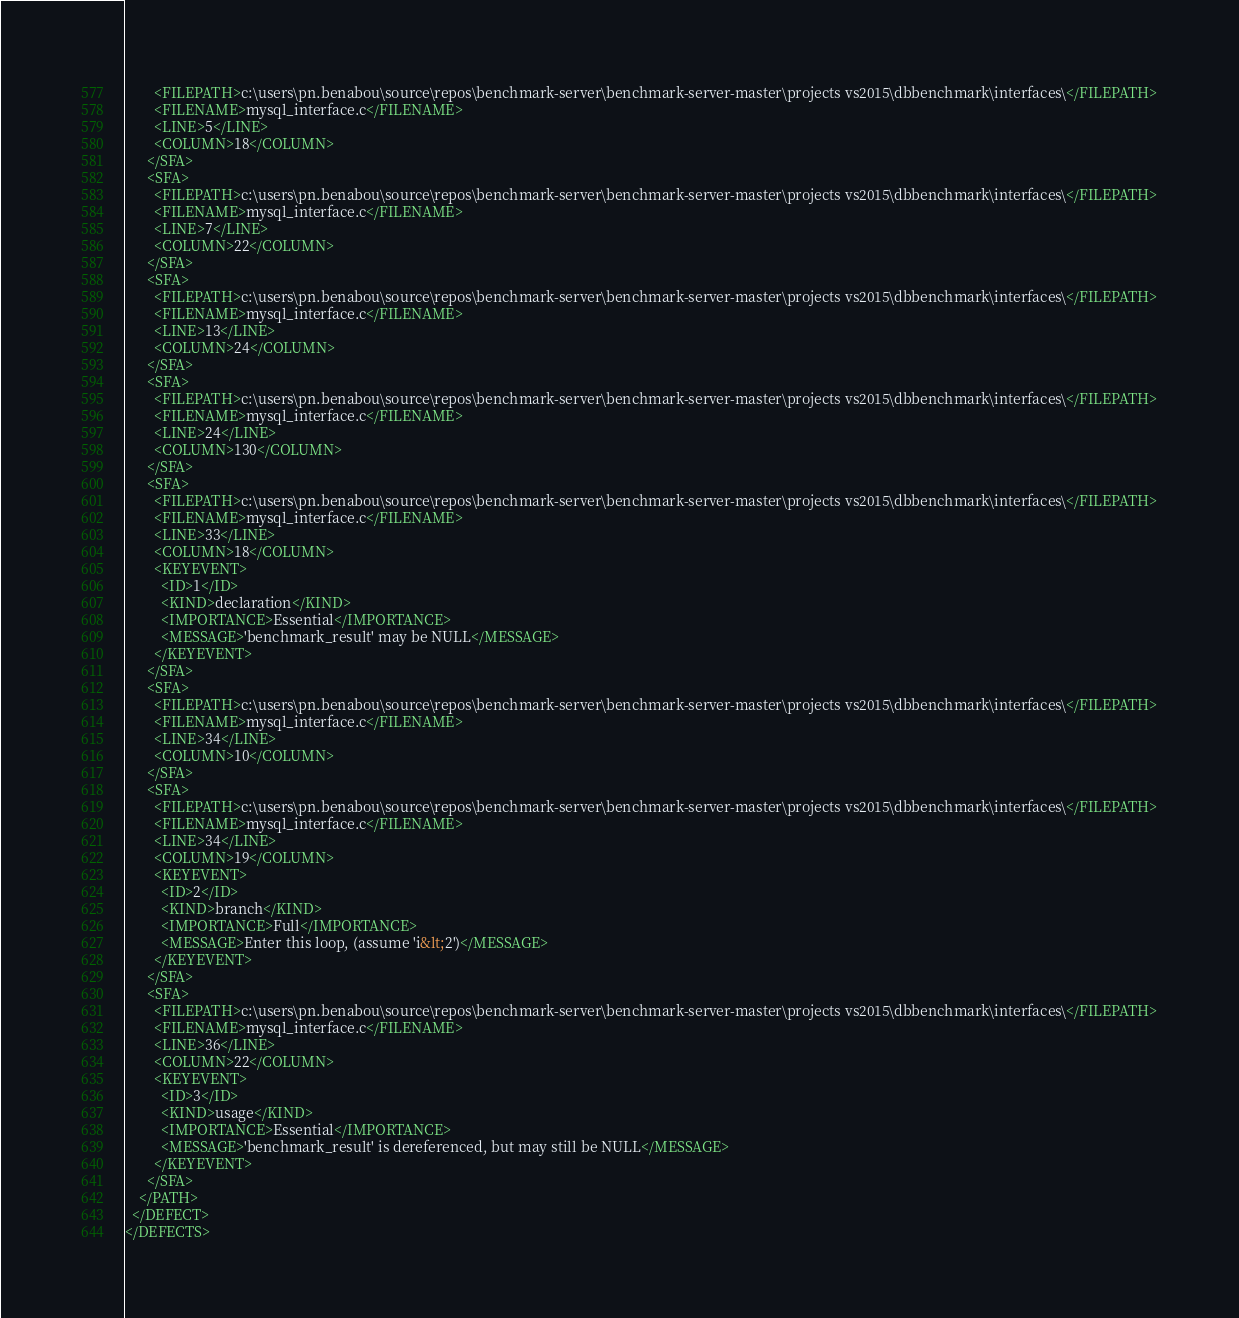<code> <loc_0><loc_0><loc_500><loc_500><_XML_>        <FILEPATH>c:\users\pn.benabou\source\repos\benchmark-server\benchmark-server-master\projects vs2015\dbbenchmark\interfaces\</FILEPATH>
        <FILENAME>mysql_interface.c</FILENAME>
        <LINE>5</LINE>
        <COLUMN>18</COLUMN>
      </SFA>
      <SFA>
        <FILEPATH>c:\users\pn.benabou\source\repos\benchmark-server\benchmark-server-master\projects vs2015\dbbenchmark\interfaces\</FILEPATH>
        <FILENAME>mysql_interface.c</FILENAME>
        <LINE>7</LINE>
        <COLUMN>22</COLUMN>
      </SFA>
      <SFA>
        <FILEPATH>c:\users\pn.benabou\source\repos\benchmark-server\benchmark-server-master\projects vs2015\dbbenchmark\interfaces\</FILEPATH>
        <FILENAME>mysql_interface.c</FILENAME>
        <LINE>13</LINE>
        <COLUMN>24</COLUMN>
      </SFA>
      <SFA>
        <FILEPATH>c:\users\pn.benabou\source\repos\benchmark-server\benchmark-server-master\projects vs2015\dbbenchmark\interfaces\</FILEPATH>
        <FILENAME>mysql_interface.c</FILENAME>
        <LINE>24</LINE>
        <COLUMN>130</COLUMN>
      </SFA>
      <SFA>
        <FILEPATH>c:\users\pn.benabou\source\repos\benchmark-server\benchmark-server-master\projects vs2015\dbbenchmark\interfaces\</FILEPATH>
        <FILENAME>mysql_interface.c</FILENAME>
        <LINE>33</LINE>
        <COLUMN>18</COLUMN>
        <KEYEVENT>
          <ID>1</ID>
          <KIND>declaration</KIND>
          <IMPORTANCE>Essential</IMPORTANCE>
          <MESSAGE>'benchmark_result' may be NULL</MESSAGE>
        </KEYEVENT>
      </SFA>
      <SFA>
        <FILEPATH>c:\users\pn.benabou\source\repos\benchmark-server\benchmark-server-master\projects vs2015\dbbenchmark\interfaces\</FILEPATH>
        <FILENAME>mysql_interface.c</FILENAME>
        <LINE>34</LINE>
        <COLUMN>10</COLUMN>
      </SFA>
      <SFA>
        <FILEPATH>c:\users\pn.benabou\source\repos\benchmark-server\benchmark-server-master\projects vs2015\dbbenchmark\interfaces\</FILEPATH>
        <FILENAME>mysql_interface.c</FILENAME>
        <LINE>34</LINE>
        <COLUMN>19</COLUMN>
        <KEYEVENT>
          <ID>2</ID>
          <KIND>branch</KIND>
          <IMPORTANCE>Full</IMPORTANCE>
          <MESSAGE>Enter this loop, (assume 'i&lt;2')</MESSAGE>
        </KEYEVENT>
      </SFA>
      <SFA>
        <FILEPATH>c:\users\pn.benabou\source\repos\benchmark-server\benchmark-server-master\projects vs2015\dbbenchmark\interfaces\</FILEPATH>
        <FILENAME>mysql_interface.c</FILENAME>
        <LINE>36</LINE>
        <COLUMN>22</COLUMN>
        <KEYEVENT>
          <ID>3</ID>
          <KIND>usage</KIND>
          <IMPORTANCE>Essential</IMPORTANCE>
          <MESSAGE>'benchmark_result' is dereferenced, but may still be NULL</MESSAGE>
        </KEYEVENT>
      </SFA>
    </PATH>
  </DEFECT>
</DEFECTS></code> 